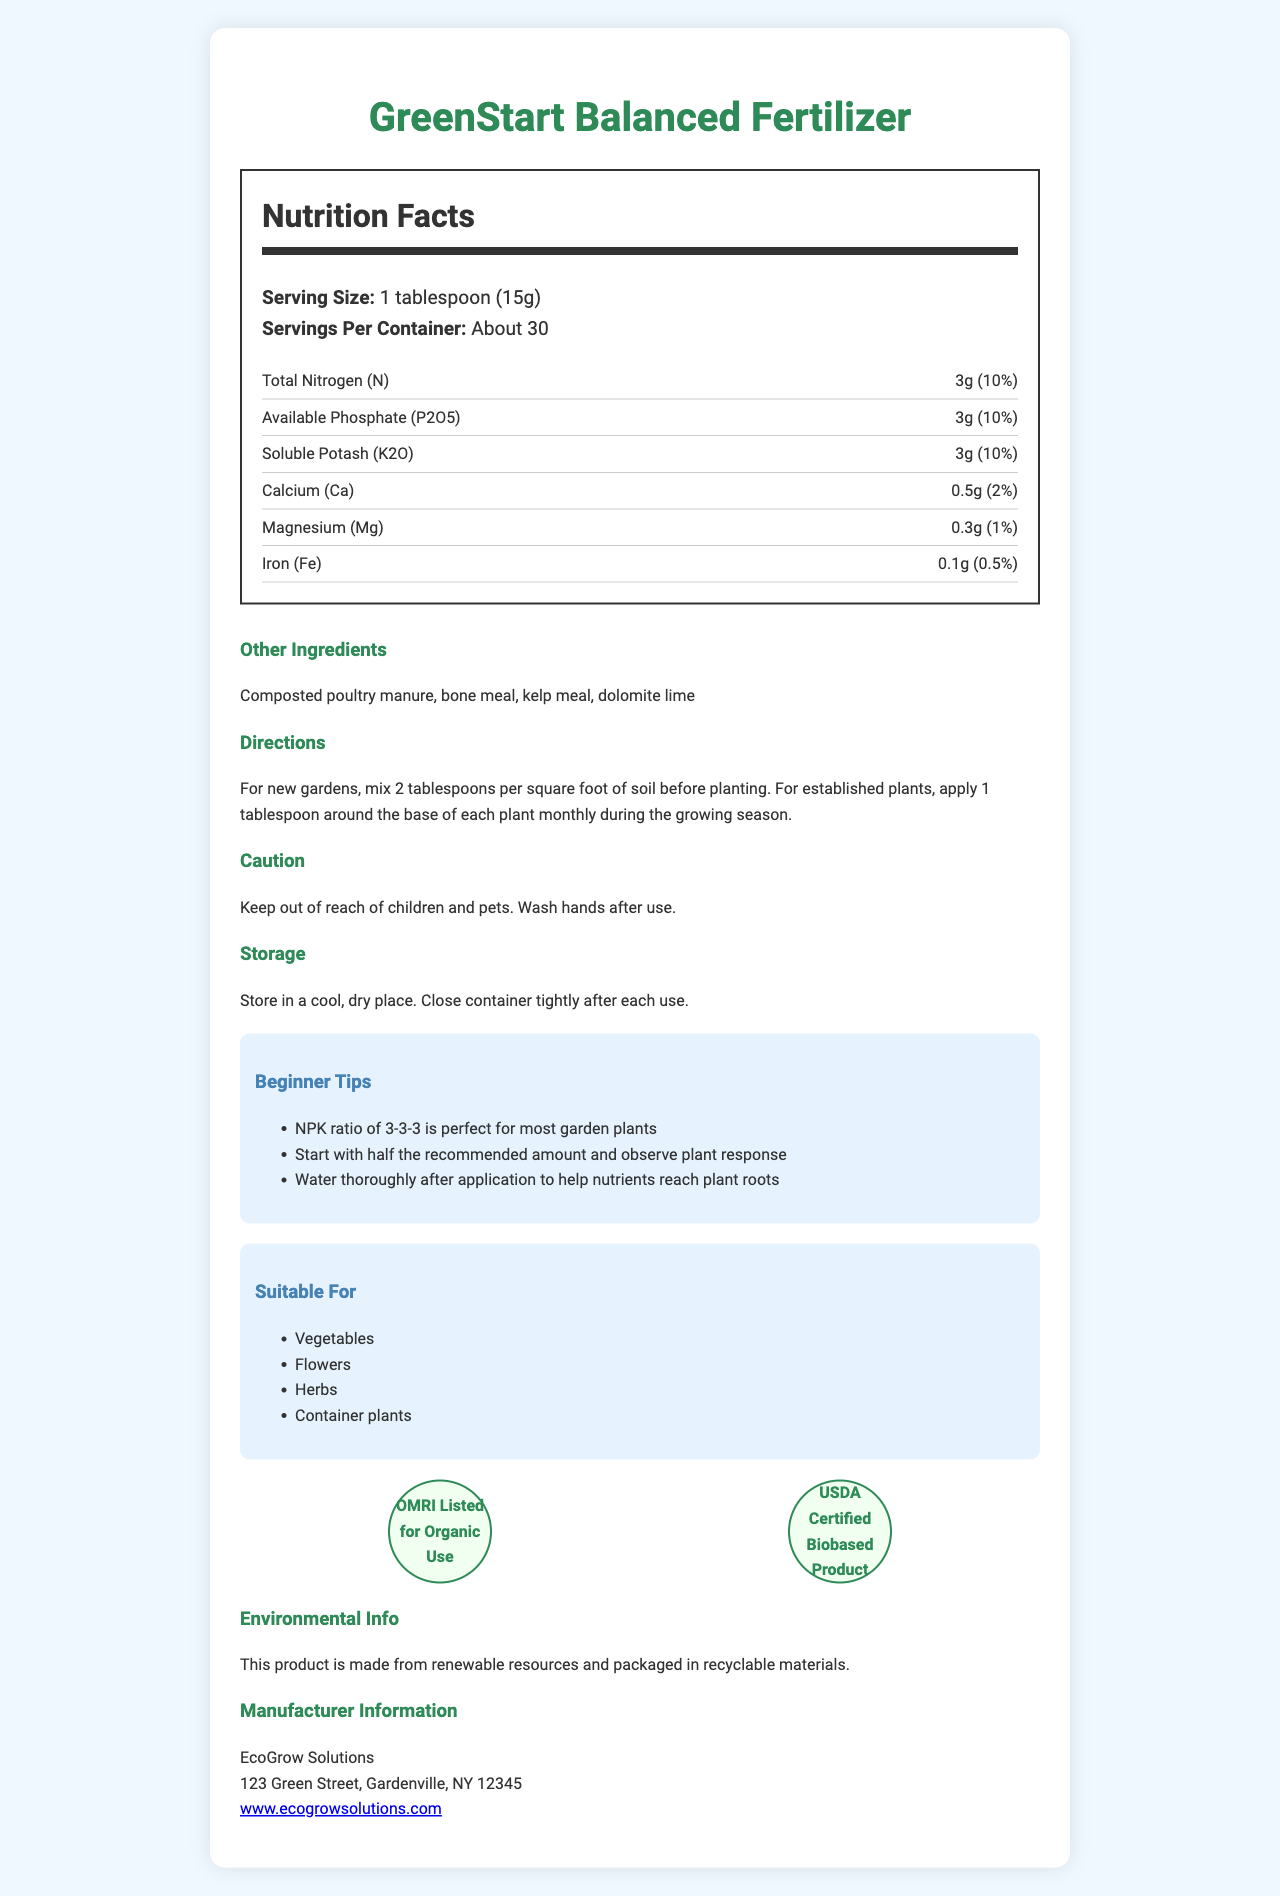what is the serving size? The serving size is listed at the beginning under "Serving Size."
Answer: 1 tablespoon (15g) how much nitrogen is in one serving? The nutrient information lists "Total Nitrogen (N)" as 3g.
Answer: 3g what is the NPK ratio of this fertilizer? The amounts of Nitrogen (N), Available Phosphate (P2O5), and Soluble Potash (K2O) are each 3g, which gives an NPK ratio of 3-3-3.
Answer: 3-3-3 which ingredient provides calcium? The "Other Ingredients" section lists dolomite lime, which is known to provide calcium.
Answer: Dolomite lime how often should this fertilizer be applied to established plants? The directions state to "apply 1 tablespoon around the base of each plant monthly during the growing season."
Answer: Monthly during the growing season what certifications does this product have? The "Certifications" section shows both these certifications.
Answer: OMRI Listed for Organic Use, USDA Certified Biobased Product is this product suitable for container plants? The "Suitable For" section lists container plants along with vegetables, flowers, and herbs.
Answer: Yes where should this product be stored? A. In a cool, dry place B. In the freezer C. Outside The "Storage" section advises storing in a cool, dry place.
Answer: A what should you do after using the fertilizer? A. Leave it alone B. Wash your hands C. Shake the container The "Caution" section advises washing your hands after use.
Answer: B which one of these is NOT an ingredient in the fertilizer? A. Kelp meal B. Blood meal C. Composted poultry manure Blood meal is not listed in the "Other Ingredients."
Answer: B is this product made from renewable resources? The "Environmental Info" section states that the product is made from renewable resources.
Answer: Yes describe the main idea of the document. The document provides a comprehensive overview of the GreenStart Balanced Fertilizer, its nutrient content, usage directions, storage instructions, and certifications.
Answer: GreenStart Balanced Fertilizer is a beginner-friendly product with a balanced NPK ratio of 3-3-3, suitable for various plants including vegetables and herbs. It is made from renewable resources, has organic certifications, and includes tips for beginners. what is the exact address of the manufacturer? The "Manufacturer Information" section lists the address.
Answer: 123 Green Street, Gardenville, NY 12345 can you mix this fertilizer directly into the water before applying to your plants? The document does not specify if the fertilizer can be mixed into water for application.
Answer: Not enough information does this product contain any iron? The nutrient information lists Iron (Fe) as 0.1g per serving.
Answer: Yes 